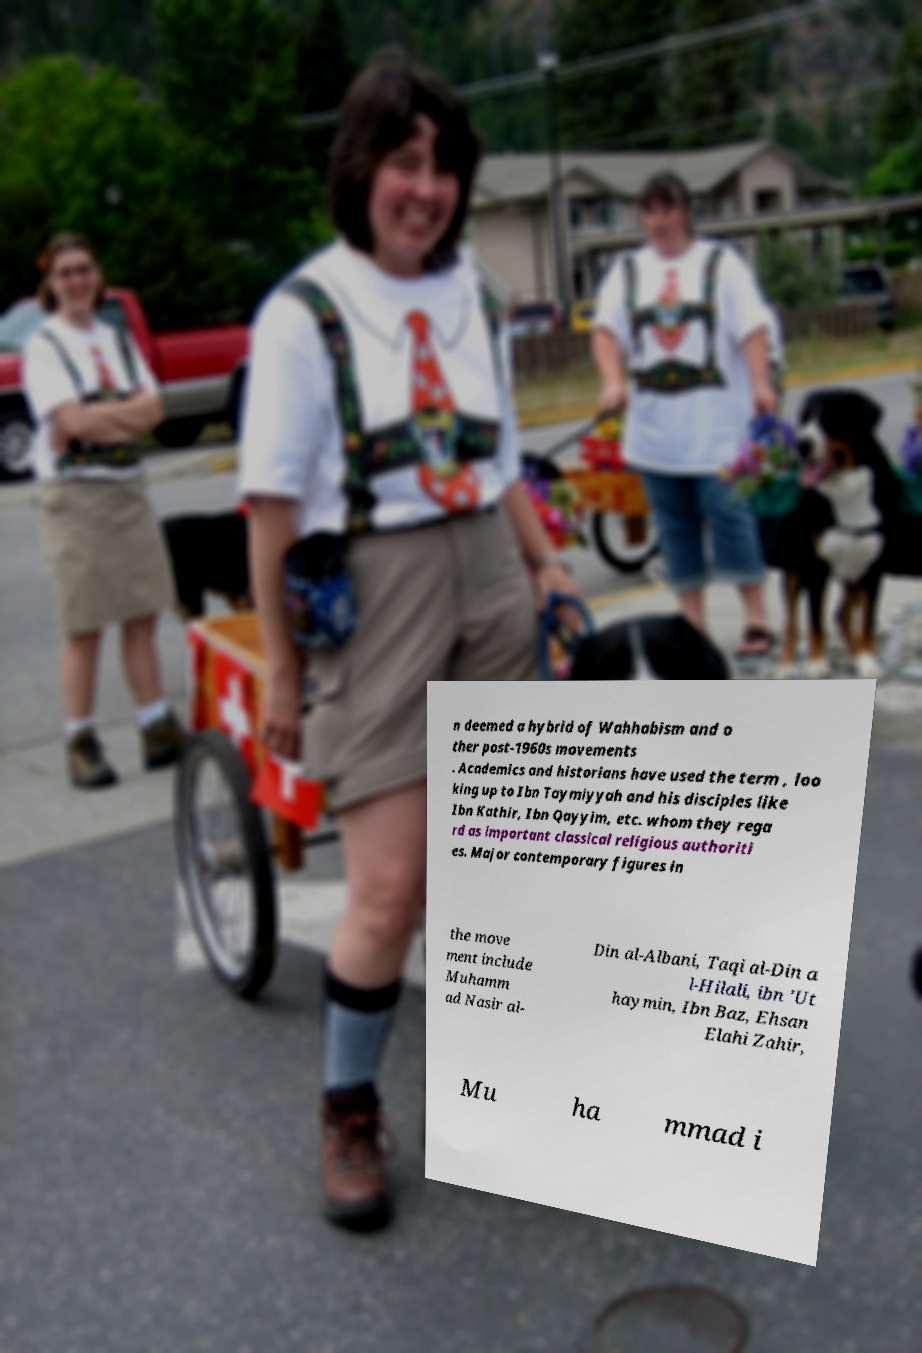Could you assist in decoding the text presented in this image and type it out clearly? n deemed a hybrid of Wahhabism and o ther post-1960s movements . Academics and historians have used the term , loo king up to Ibn Taymiyyah and his disciples like Ibn Kathir, Ibn Qayyim, etc. whom they rega rd as important classical religious authoriti es. Major contemporary figures in the move ment include Muhamm ad Nasir al- Din al-Albani, Taqi al-Din a l-Hilali, ibn 'Ut haymin, Ibn Baz, Ehsan Elahi Zahir, Mu ha mmad i 